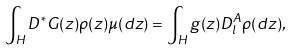Convert formula to latex. <formula><loc_0><loc_0><loc_500><loc_500>\int _ { H } D ^ { * } G ( z ) \rho ( z ) \mu ( d z ) = \int _ { H } g ( z ) D _ { l } ^ { A } \rho ( d z ) ,</formula> 